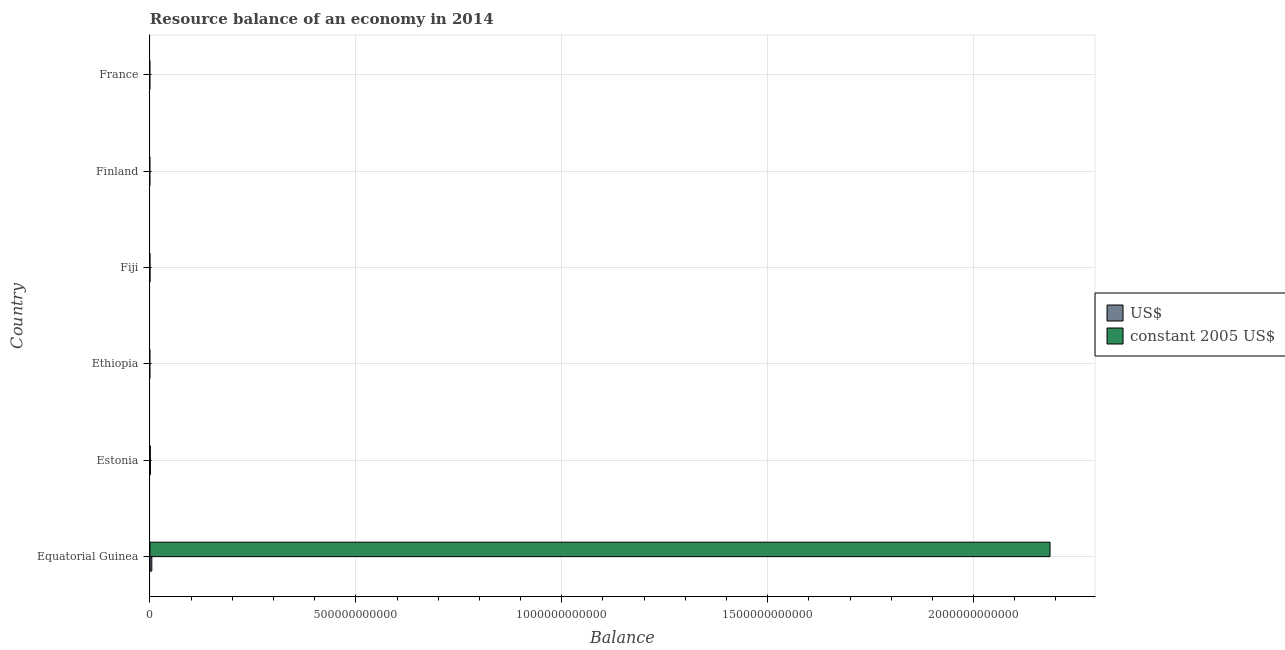Are the number of bars on each tick of the Y-axis equal?
Provide a succinct answer. No. How many bars are there on the 5th tick from the top?
Your answer should be compact. 2. How many bars are there on the 4th tick from the bottom?
Your response must be concise. 0. What is the resource balance in constant us$ in Equatorial Guinea?
Provide a short and direct response. 2.19e+12. Across all countries, what is the maximum resource balance in us$?
Offer a terse response. 4.42e+09. In which country was the resource balance in constant us$ maximum?
Keep it short and to the point. Equatorial Guinea. What is the total resource balance in us$ in the graph?
Make the answer very short. 5.32e+09. What is the difference between the resource balance in constant us$ in Equatorial Guinea and that in Estonia?
Provide a short and direct response. 2.18e+12. What is the difference between the resource balance in constant us$ in Fiji and the resource balance in us$ in Finland?
Offer a very short reply. 0. What is the average resource balance in us$ per country?
Provide a short and direct response. 8.87e+08. What is the difference between the resource balance in us$ and resource balance in constant us$ in Equatorial Guinea?
Keep it short and to the point. -2.18e+12. What is the difference between the highest and the lowest resource balance in constant us$?
Keep it short and to the point. 2.19e+12. Is the sum of the resource balance in us$ in Equatorial Guinea and Estonia greater than the maximum resource balance in constant us$ across all countries?
Give a very brief answer. No. How many bars are there?
Provide a short and direct response. 4. Are all the bars in the graph horizontal?
Give a very brief answer. Yes. How many countries are there in the graph?
Give a very brief answer. 6. What is the difference between two consecutive major ticks on the X-axis?
Your response must be concise. 5.00e+11. Are the values on the major ticks of X-axis written in scientific E-notation?
Your answer should be very brief. No. Does the graph contain any zero values?
Keep it short and to the point. Yes. How are the legend labels stacked?
Your response must be concise. Vertical. What is the title of the graph?
Your answer should be very brief. Resource balance of an economy in 2014. Does "Automatic Teller Machines" appear as one of the legend labels in the graph?
Your answer should be very brief. No. What is the label or title of the X-axis?
Offer a terse response. Balance. What is the label or title of the Y-axis?
Make the answer very short. Country. What is the Balance of US$ in Equatorial Guinea?
Your answer should be compact. 4.42e+09. What is the Balance in constant 2005 US$ in Equatorial Guinea?
Offer a terse response. 2.19e+12. What is the Balance in US$ in Estonia?
Your answer should be compact. 9.04e+08. What is the Balance of constant 2005 US$ in Estonia?
Your answer should be compact. 6.81e+08. What is the Balance of US$ in Ethiopia?
Your answer should be very brief. 0. What is the Balance in constant 2005 US$ in France?
Your response must be concise. 0. Across all countries, what is the maximum Balance of US$?
Keep it short and to the point. 4.42e+09. Across all countries, what is the maximum Balance of constant 2005 US$?
Your answer should be compact. 2.19e+12. What is the total Balance in US$ in the graph?
Your answer should be very brief. 5.32e+09. What is the total Balance in constant 2005 US$ in the graph?
Offer a terse response. 2.19e+12. What is the difference between the Balance in US$ in Equatorial Guinea and that in Estonia?
Ensure brevity in your answer.  3.52e+09. What is the difference between the Balance in constant 2005 US$ in Equatorial Guinea and that in Estonia?
Provide a short and direct response. 2.18e+12. What is the difference between the Balance of US$ in Equatorial Guinea and the Balance of constant 2005 US$ in Estonia?
Your answer should be very brief. 3.74e+09. What is the average Balance in US$ per country?
Provide a succinct answer. 8.87e+08. What is the average Balance of constant 2005 US$ per country?
Ensure brevity in your answer.  3.64e+11. What is the difference between the Balance of US$ and Balance of constant 2005 US$ in Equatorial Guinea?
Give a very brief answer. -2.18e+12. What is the difference between the Balance in US$ and Balance in constant 2005 US$ in Estonia?
Keep it short and to the point. 2.23e+08. What is the ratio of the Balance of US$ in Equatorial Guinea to that in Estonia?
Offer a terse response. 4.89. What is the ratio of the Balance in constant 2005 US$ in Equatorial Guinea to that in Estonia?
Make the answer very short. 3208.85. What is the difference between the highest and the lowest Balance of US$?
Ensure brevity in your answer.  4.42e+09. What is the difference between the highest and the lowest Balance in constant 2005 US$?
Keep it short and to the point. 2.19e+12. 